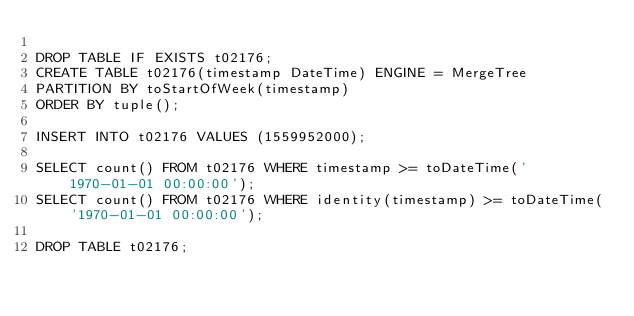Convert code to text. <code><loc_0><loc_0><loc_500><loc_500><_SQL_>
DROP TABLE IF EXISTS t02176;
CREATE TABLE t02176(timestamp DateTime) ENGINE = MergeTree
PARTITION BY toStartOfWeek(timestamp)
ORDER BY tuple();

INSERT INTO t02176 VALUES (1559952000);

SELECT count() FROM t02176 WHERE timestamp >= toDateTime('1970-01-01 00:00:00');
SELECT count() FROM t02176 WHERE identity(timestamp) >= toDateTime('1970-01-01 00:00:00');

DROP TABLE t02176;
</code> 